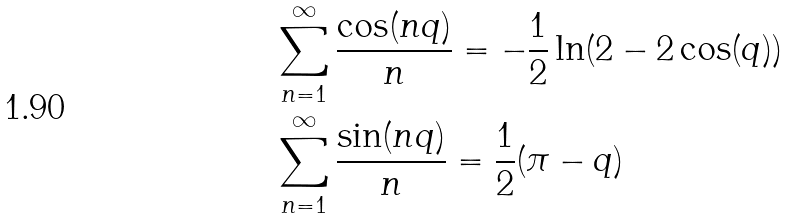Convert formula to latex. <formula><loc_0><loc_0><loc_500><loc_500>& \sum _ { n = 1 } ^ { \infty } \frac { \cos ( n q ) } { n } = - \frac { 1 } { 2 } \ln ( 2 - 2 \cos ( q ) ) \\ & \sum _ { n = 1 } ^ { \infty } \frac { \sin ( n q ) } { n } = \frac { 1 } { 2 } ( \pi - q )</formula> 